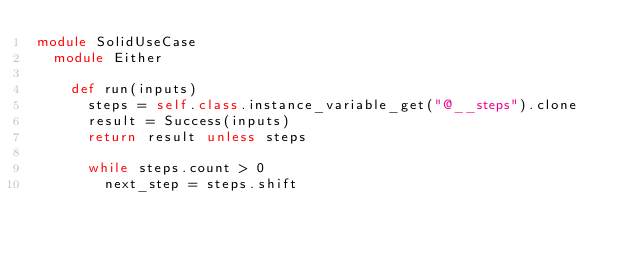<code> <loc_0><loc_0><loc_500><loc_500><_Ruby_>module SolidUseCase
  module Either

    def run(inputs)
      steps = self.class.instance_variable_get("@__steps").clone
      result = Success(inputs)
      return result unless steps

      while steps.count > 0
        next_step = steps.shift
</code> 